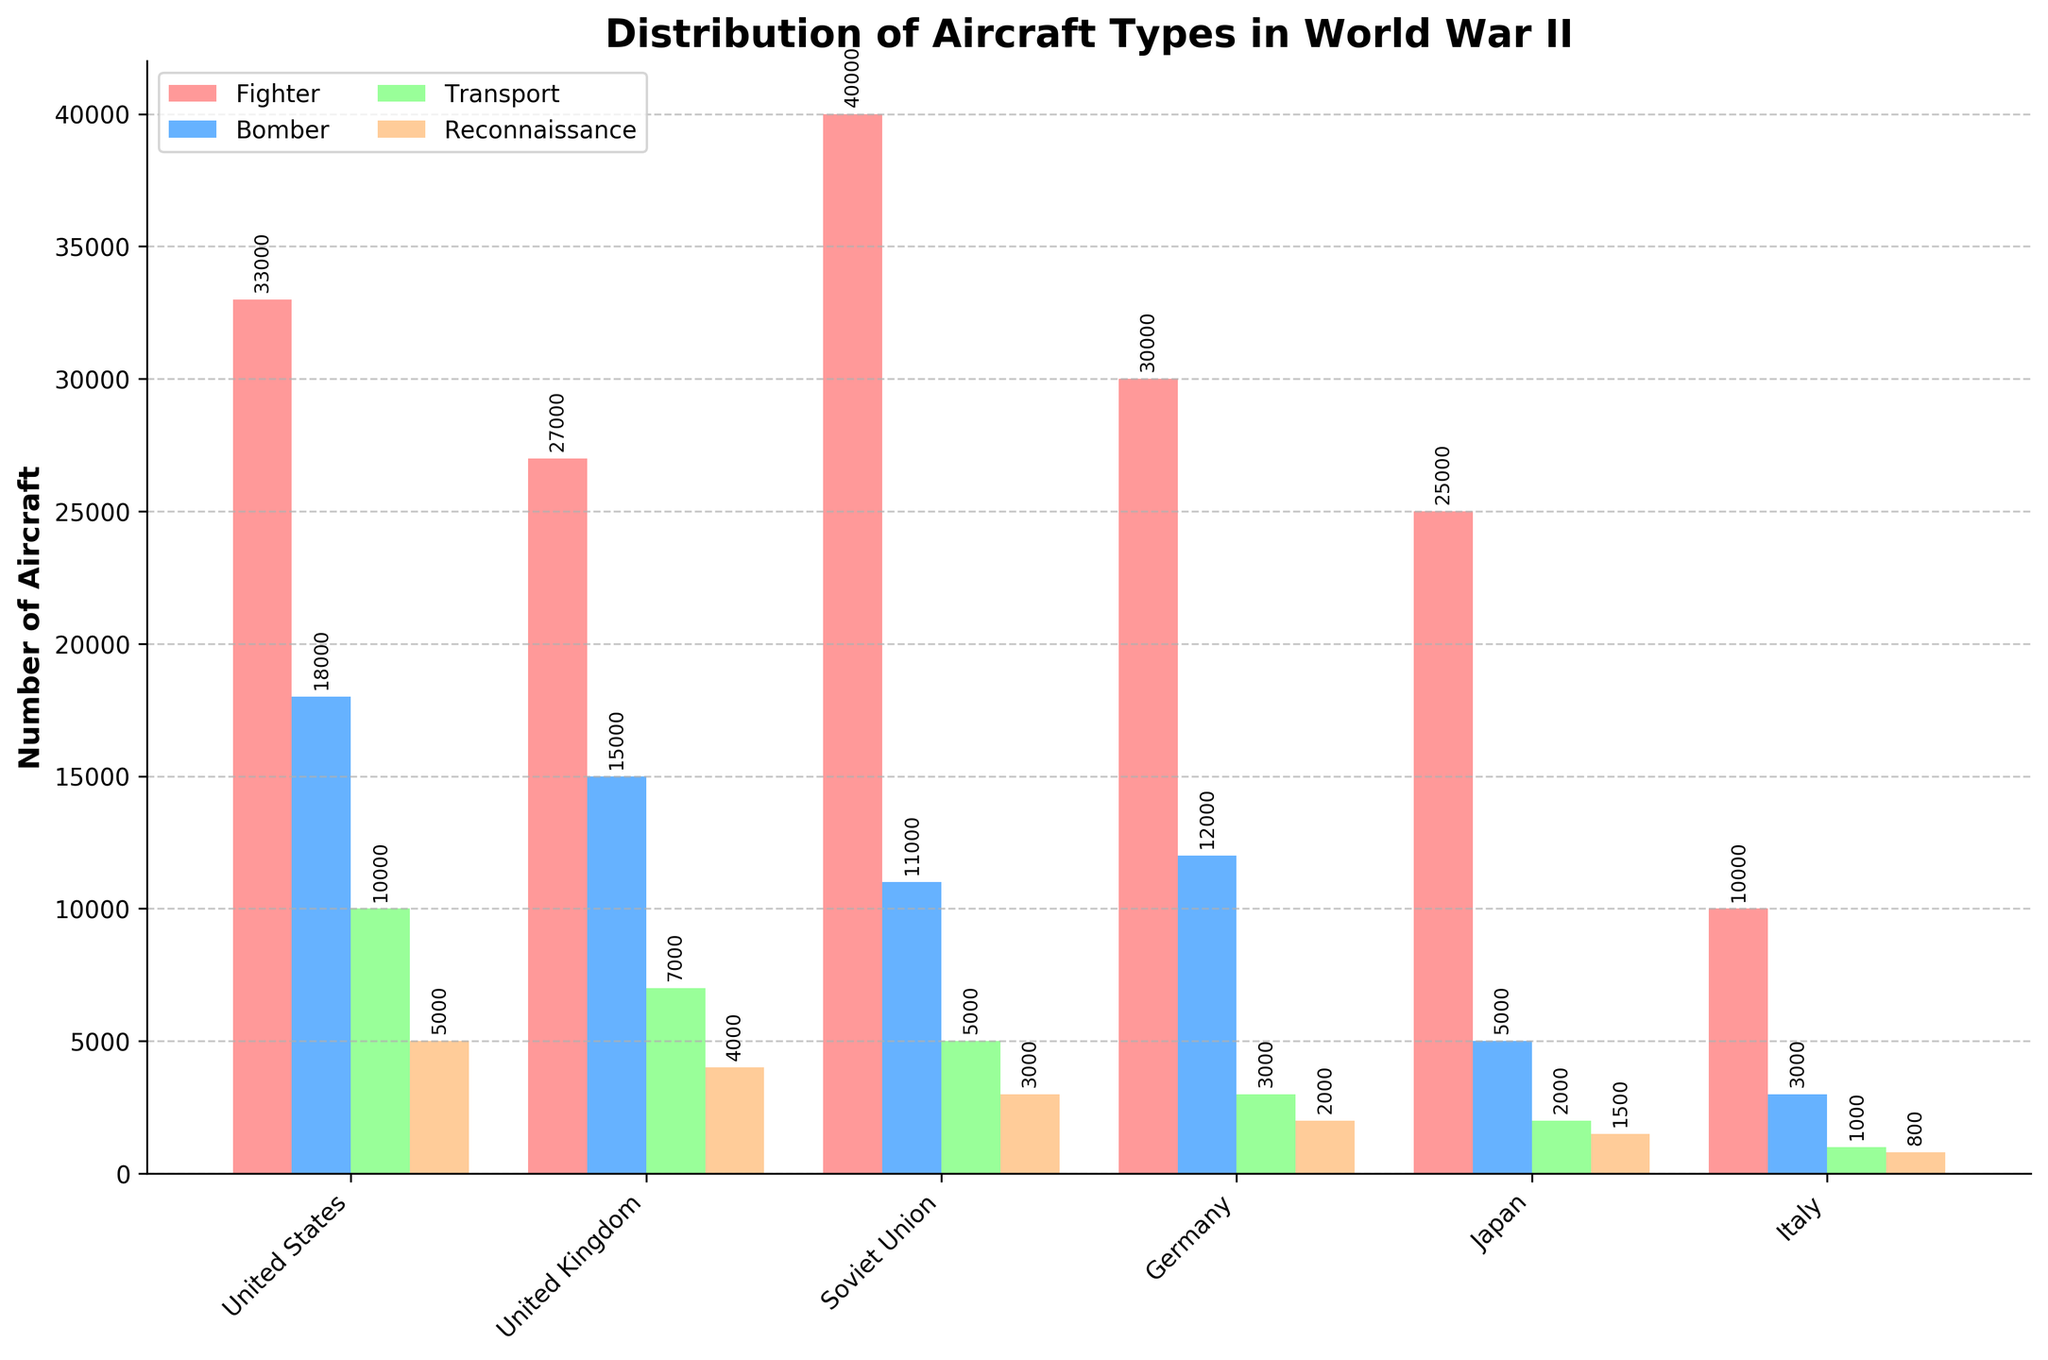Which country had the highest number of fighter aircraft? United States had the highest number of fighter aircraft. The height of the red bar (indicating Fighters) for the United States is taller than all other fighter bars for other countries.
Answer: United States Which country had fewer bombers than fighters? By comparing the heights of the bars representing bombers (blue) and fighters (red) in the chart for each country, all countries had fewer bombers than fighters. This is indicated by the shorter blue bars compared to the red bars.
Answer: All countries How many reconnaissance aircraft did Germany and Italy have combined? Adding the number of reconnaissance aircraft Germany had (2000) to the number Italy had (800) gives us a total (2000 + 800).
Answer: 2800 Which country's transport aircraft numbers are closest to 5000? By comparing the height of the green bars (representing Transport) to the value 5000, the Soviet Union has exactly 5000 transport aircraft.
Answer: Soviet Union Which aircraft type was most prevalent in Japan's fleet? The tallest bar for Japan is the red bar, which indicates Fighters. Therefore, Fighters were the most prevalent aircraft type in Japan's fleet.
Answer: Fighters Did the United Kingdom or the Soviet Union have more reconnaissance aircraft? The height of the grey bar (Reconnaissance) for the Soviet Union is slightly taller than the grey bar for the United Kingdom, indicating the Soviet Union had more reconnaissance aircraft.
Answer: Soviet Union What is the total number of bombers used by the United States and the United Kingdom together? Adding the number of bombers used by the United States (18000) and the United Kingdom (15000) yields a total of 33000 (18000 + 15000).
Answer: 33000 Which country had the smallest number of transport aircraft? The shortest green bar, representing transport aircraft, belongs to Italy, indicating it had the smallest number of transport aircraft.
Answer: Italy By how much does the number of Japanese fighter aircraft exceed the number of Japanese transport aircraft? Subtracting the number of Japanese transport aircraft (2000) from the number of Japanese fighter aircraft (25000) reveals the difference, which is 25000 - 2000 = 23000.
Answer: 23000 